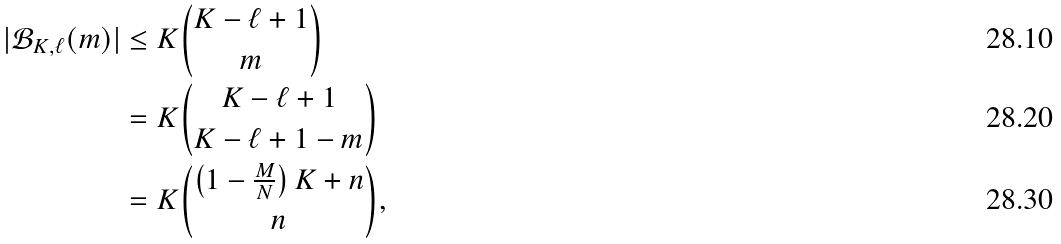Convert formula to latex. <formula><loc_0><loc_0><loc_500><loc_500>| \mathcal { B } _ { K , \ell } ( m ) | & \leq K \binom { K - \ell + 1 } { m } \\ & = K \binom { K - \ell + 1 } { K - \ell + 1 - m } \\ & = K \binom { \left ( 1 - \frac { M } { N } \right ) K + n } { n } ,</formula> 